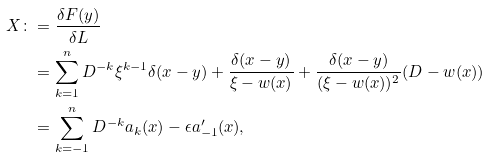<formula> <loc_0><loc_0><loc_500><loc_500>X \colon & = \frac { \delta F ( y ) } { \delta L } \\ & = \sum _ { k = 1 } ^ { n } D ^ { - k } \xi ^ { k - 1 } \delta ( x - y ) + \frac { \delta ( x - y ) } { \xi - w ( x ) } + \frac { \delta ( x - y ) } { ( \xi - w ( x ) ) ^ { 2 } } ( D - w ( x ) ) \\ & = \sum _ { k = - 1 } ^ { n } D ^ { - k } a _ { k } ( x ) - \epsilon a _ { - 1 } ^ { \prime } ( x ) ,</formula> 